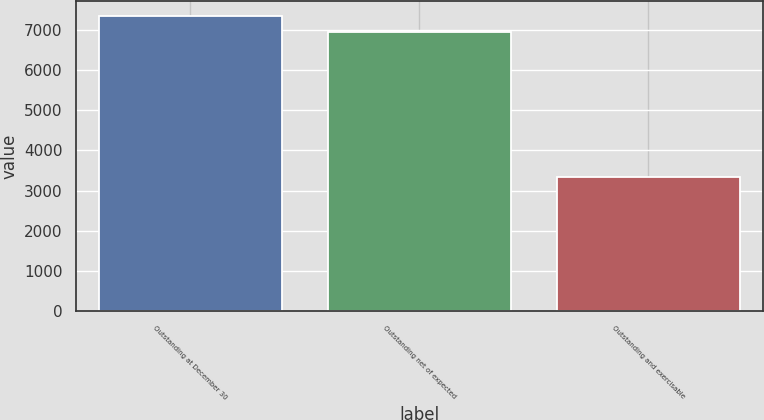Convert chart to OTSL. <chart><loc_0><loc_0><loc_500><loc_500><bar_chart><fcel>Outstanding at December 30<fcel>Outstanding net of expected<fcel>Outstanding and exercisable<nl><fcel>7347.8<fcel>6955<fcel>3341<nl></chart> 